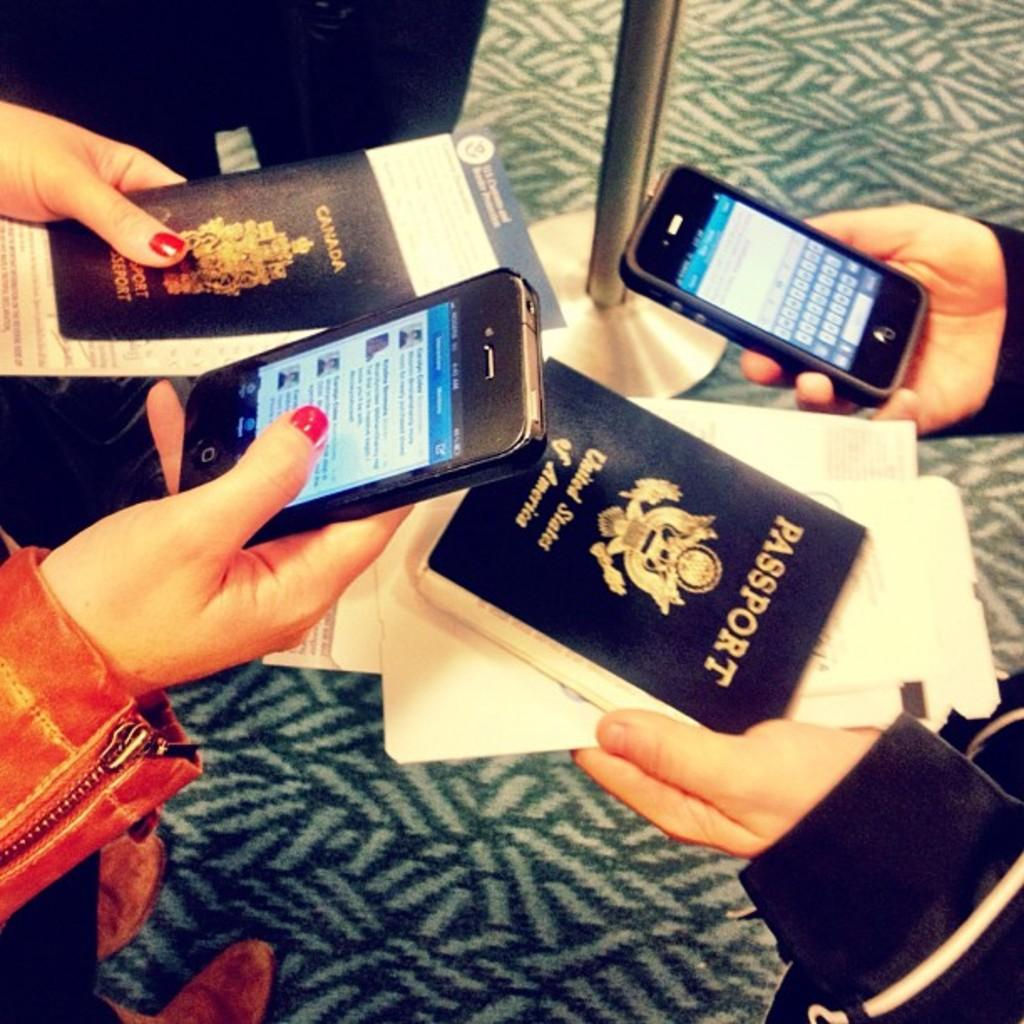<image>
Render a clear and concise summary of the photo. Two people with cellphones and a passport from the USA. 